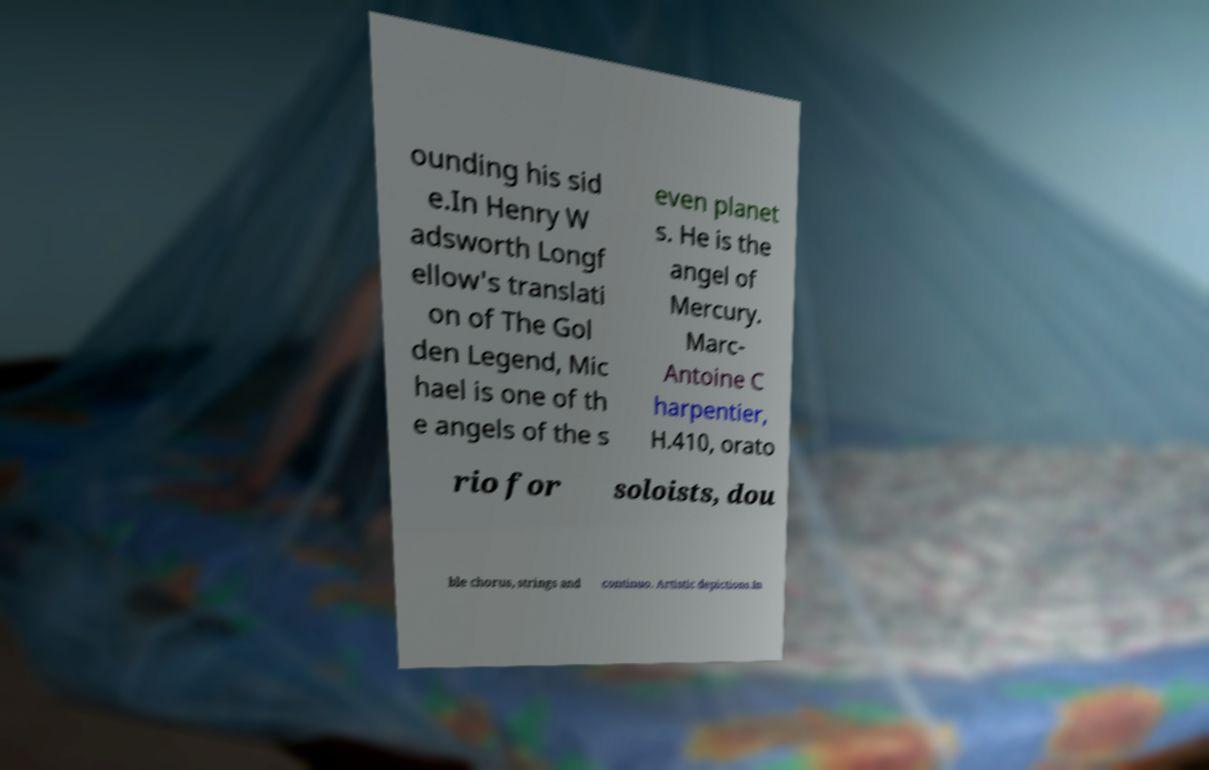What messages or text are displayed in this image? I need them in a readable, typed format. ounding his sid e.In Henry W adsworth Longf ellow's translati on of The Gol den Legend, Mic hael is one of th e angels of the s even planet s. He is the angel of Mercury. Marc- Antoine C harpentier, H.410, orato rio for soloists, dou ble chorus, strings and continuo. Artistic depictions.In 